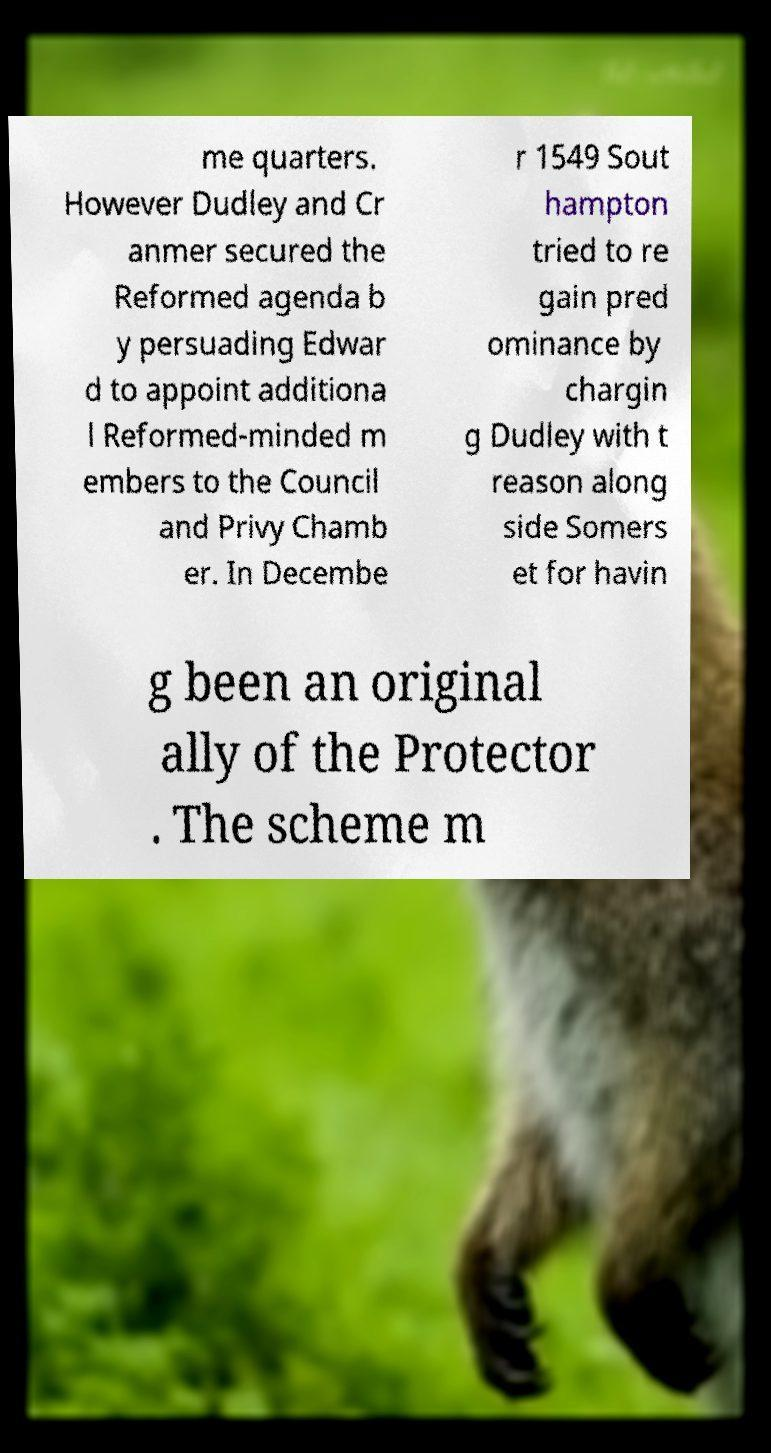There's text embedded in this image that I need extracted. Can you transcribe it verbatim? me quarters. However Dudley and Cr anmer secured the Reformed agenda b y persuading Edwar d to appoint additiona l Reformed-minded m embers to the Council and Privy Chamb er. In Decembe r 1549 Sout hampton tried to re gain pred ominance by chargin g Dudley with t reason along side Somers et for havin g been an original ally of the Protector . The scheme m 